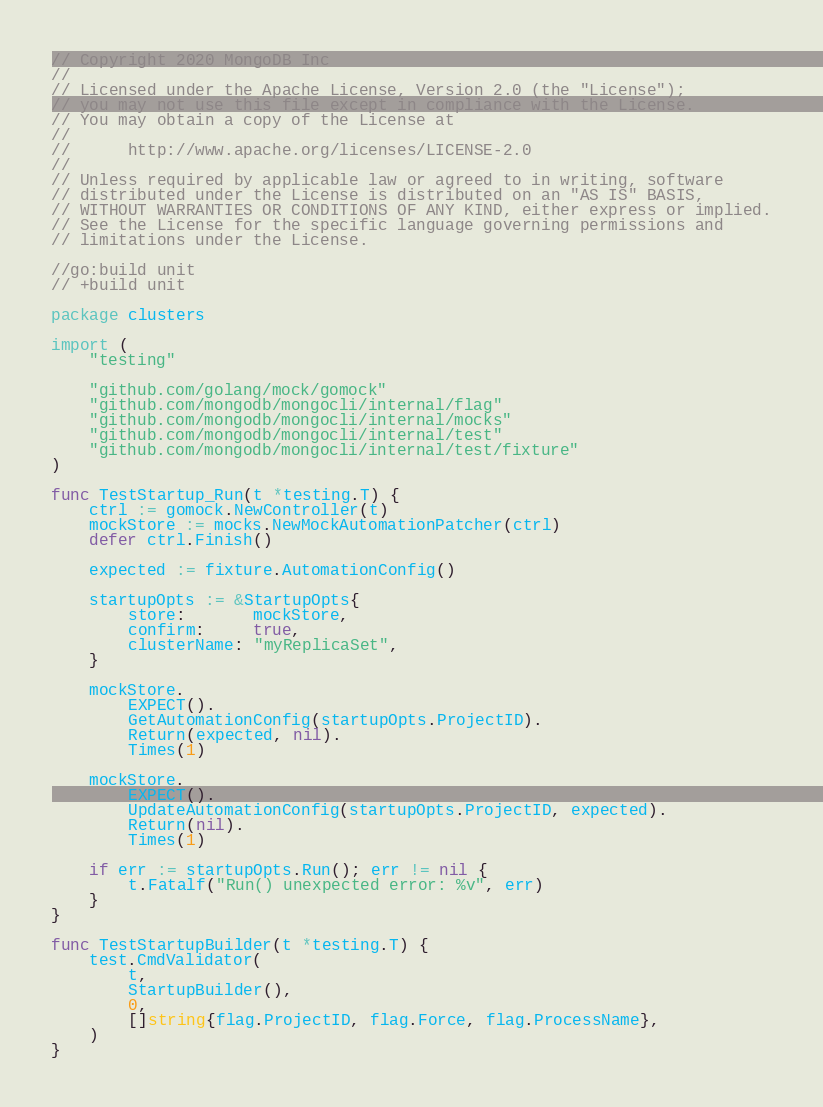Convert code to text. <code><loc_0><loc_0><loc_500><loc_500><_Go_>// Copyright 2020 MongoDB Inc
//
// Licensed under the Apache License, Version 2.0 (the "License");
// you may not use this file except in compliance with the License.
// You may obtain a copy of the License at
//
//      http://www.apache.org/licenses/LICENSE-2.0
//
// Unless required by applicable law or agreed to in writing, software
// distributed under the License is distributed on an "AS IS" BASIS,
// WITHOUT WARRANTIES OR CONDITIONS OF ANY KIND, either express or implied.
// See the License for the specific language governing permissions and
// limitations under the License.

//go:build unit
// +build unit

package clusters

import (
	"testing"

	"github.com/golang/mock/gomock"
	"github.com/mongodb/mongocli/internal/flag"
	"github.com/mongodb/mongocli/internal/mocks"
	"github.com/mongodb/mongocli/internal/test"
	"github.com/mongodb/mongocli/internal/test/fixture"
)

func TestStartup_Run(t *testing.T) {
	ctrl := gomock.NewController(t)
	mockStore := mocks.NewMockAutomationPatcher(ctrl)
	defer ctrl.Finish()

	expected := fixture.AutomationConfig()

	startupOpts := &StartupOpts{
		store:       mockStore,
		confirm:     true,
		clusterName: "myReplicaSet",
	}

	mockStore.
		EXPECT().
		GetAutomationConfig(startupOpts.ProjectID).
		Return(expected, nil).
		Times(1)

	mockStore.
		EXPECT().
		UpdateAutomationConfig(startupOpts.ProjectID, expected).
		Return(nil).
		Times(1)

	if err := startupOpts.Run(); err != nil {
		t.Fatalf("Run() unexpected error: %v", err)
	}
}

func TestStartupBuilder(t *testing.T) {
	test.CmdValidator(
		t,
		StartupBuilder(),
		0,
		[]string{flag.ProjectID, flag.Force, flag.ProcessName},
	)
}
</code> 